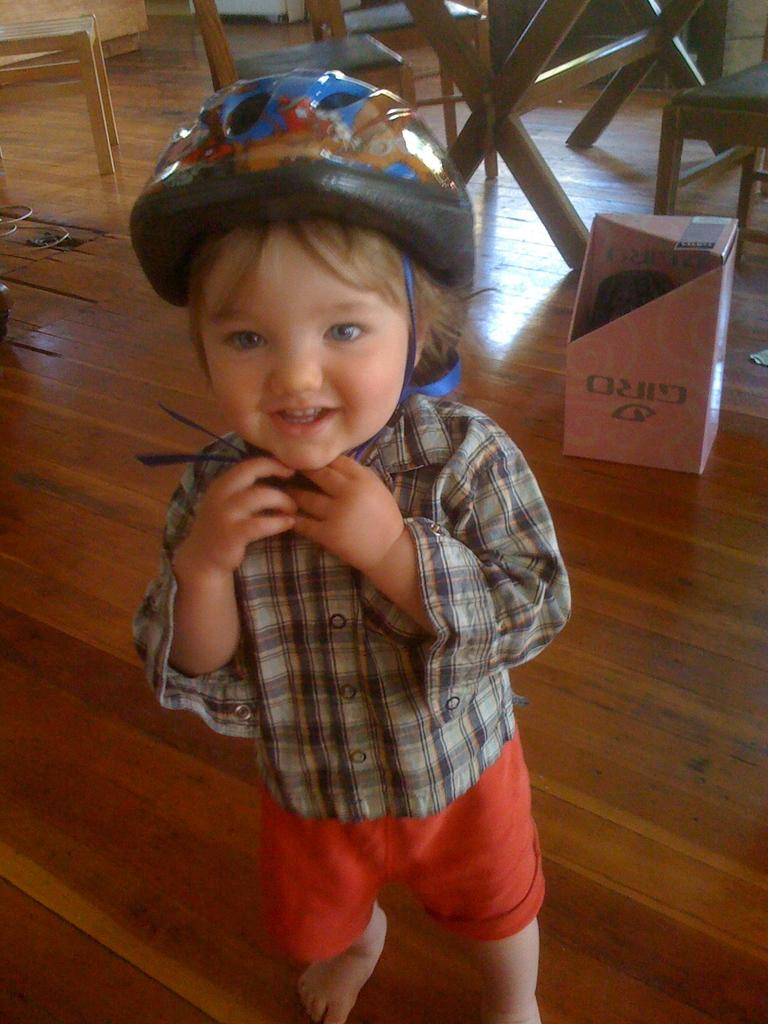Who or what is the main subject in the image? There is a person in the image. What is the person wearing on their head? The person is wearing a blue cap. What type of furniture can be seen in the background of the image? There are chairs and a table in the background of the image. What type of border can be seen in the image? There is no border present in the image. How many airports are visible in the image? There are no airports visible in the image. 